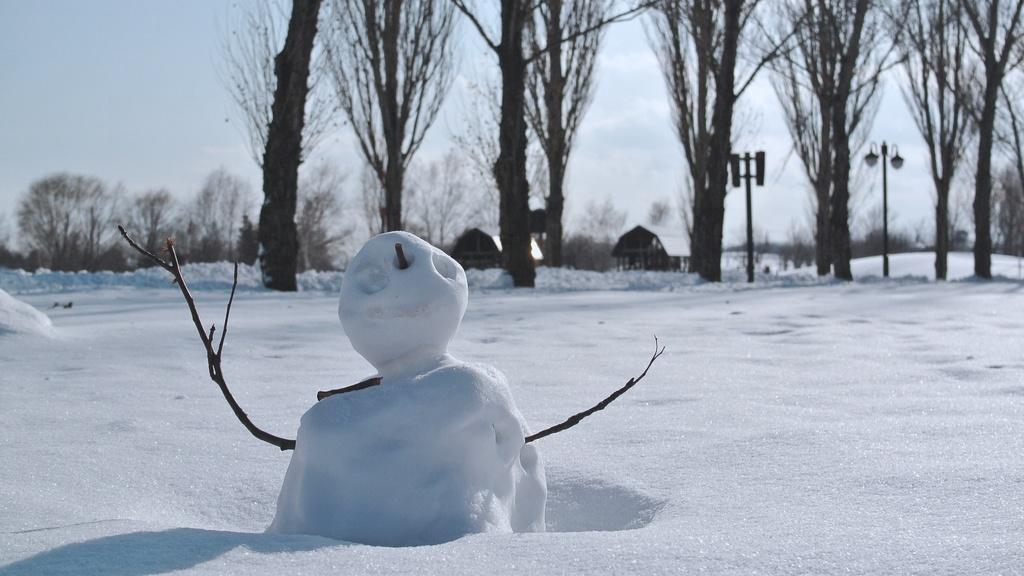Can you describe this image briefly? In this image, I can see a snowman. This is the snow. These are the trees. In the background, I can see the small houses. I think this is a light pole. I can see the sky. 